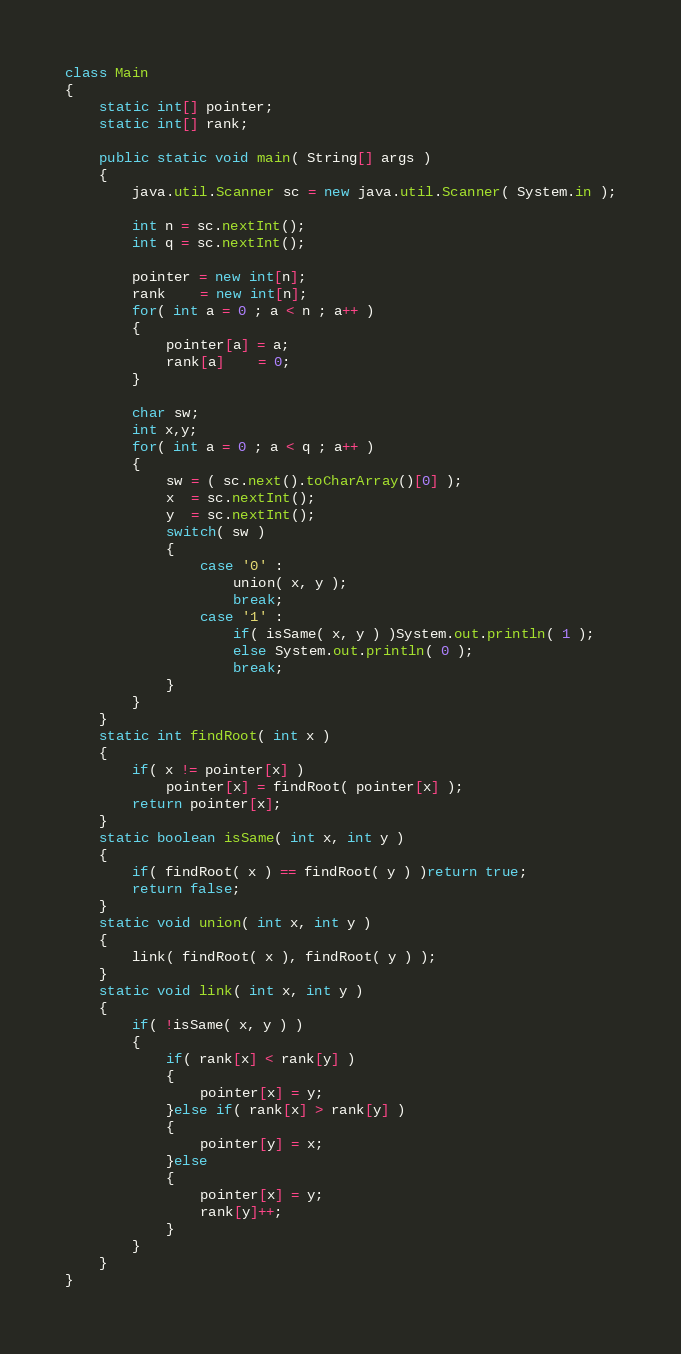Convert code to text. <code><loc_0><loc_0><loc_500><loc_500><_Java_>class Main
{
	static int[] pointer;
	static int[] rank;
	
	public static void main( String[] args )
	{
		java.util.Scanner sc = new java.util.Scanner( System.in );
		
		int n = sc.nextInt();
		int q = sc.nextInt();
		
		pointer = new int[n];
		rank    = new int[n];
		for( int a = 0 ; a < n ; a++ )
		{
			pointer[a] = a;
			rank[a]    = 0;
		}
		
		char sw;
		int x,y;
		for( int a = 0 ; a < q ; a++ )
		{
			sw = ( sc.next().toCharArray()[0] );
			x  = sc.nextInt();
			y  = sc.nextInt();
			switch( sw )
			{
				case '0' : 
					union( x, y );
					break;
				case '1' :
					if( isSame( x, y ) )System.out.println( 1 );
					else System.out.println( 0 );
					break;
			}
		}
	}
	static int findRoot( int x )
	{
		if( x != pointer[x] )
			pointer[x] = findRoot( pointer[x] );
		return pointer[x];
	}
	static boolean isSame( int x, int y )
	{
		if( findRoot( x ) == findRoot( y ) )return true;
		return false;
	}
	static void union( int x, int y )
	{
		link( findRoot( x ), findRoot( y ) );
	}
	static void link( int x, int y )
	{
		if( !isSame( x, y ) )
		{
			if( rank[x] < rank[y] )
			{
				pointer[x] = y;
			}else if( rank[x] > rank[y] )
			{
				pointer[y] = x;
			}else
			{
				pointer[x] = y;
				rank[y]++;
			}
		}
	}
}</code> 